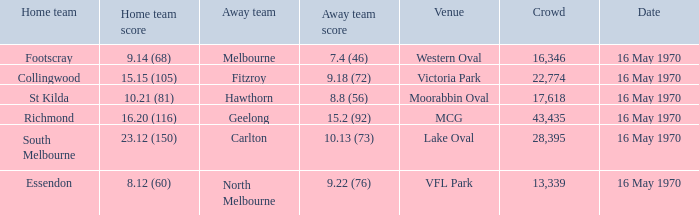Who was the non-home team at western oval? Melbourne. 